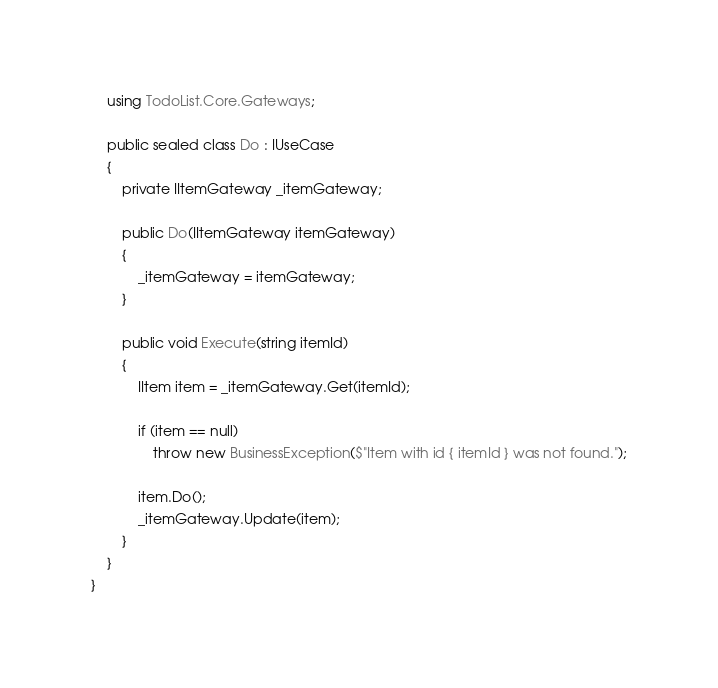Convert code to text. <code><loc_0><loc_0><loc_500><loc_500><_C#_>    using TodoList.Core.Gateways;

    public sealed class Do : IUseCase
    {
        private IItemGateway _itemGateway;

        public Do(IItemGateway itemGateway)
        {
            _itemGateway = itemGateway;
        }

        public void Execute(string itemId)
        {
            IItem item = _itemGateway.Get(itemId);

            if (item == null)
                throw new BusinessException($"Item with id { itemId } was not found.");

            item.Do();
            _itemGateway.Update(item);
        }
    }
}</code> 